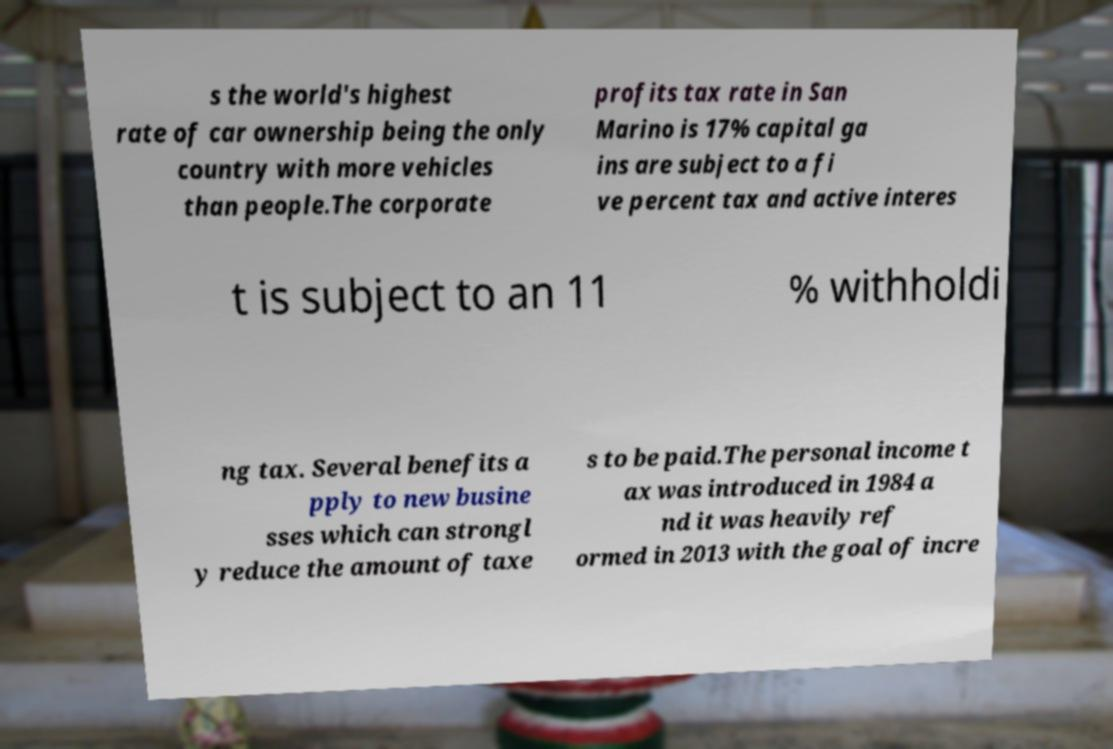For documentation purposes, I need the text within this image transcribed. Could you provide that? s the world's highest rate of car ownership being the only country with more vehicles than people.The corporate profits tax rate in San Marino is 17% capital ga ins are subject to a fi ve percent tax and active interes t is subject to an 11 % withholdi ng tax. Several benefits a pply to new busine sses which can strongl y reduce the amount of taxe s to be paid.The personal income t ax was introduced in 1984 a nd it was heavily ref ormed in 2013 with the goal of incre 